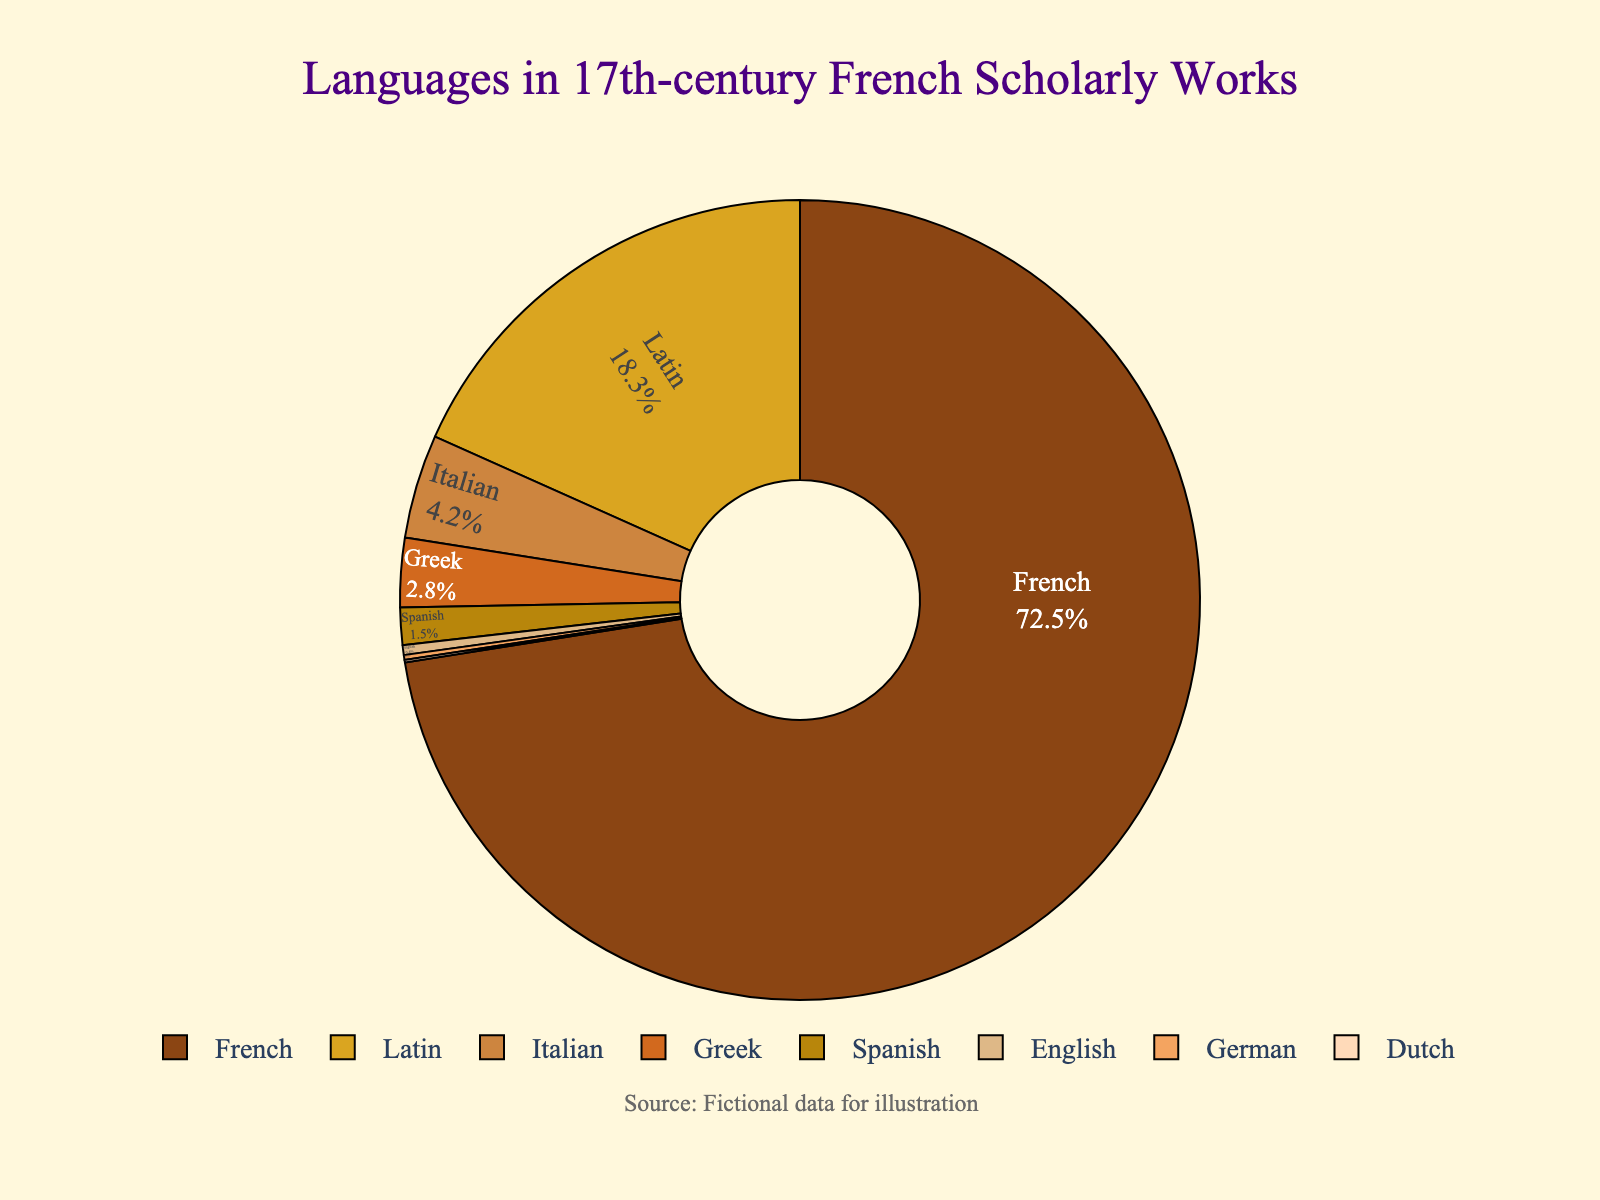Which language is used the most in 17th-century French scholarly works? The pie chart shows that French is the largest segment, indicating it is the most used language in these works.
Answer: French What is the combined percentage of Latin and Greek? By looking at the pie chart, we see Latin has 18.3% and Greek has 2.8%. Adding these together gives 18.3 + 2.8 = 21.1%.
Answer: 21.1% Which languages have a usage percentage higher than 2%? Observing the pie chart, the languages with usage percentages higher than 2% are French (72.5%), Latin (18.3%), Italian (4.2%), and Greek (2.8%).
Answer: French, Latin, Italian, Greek How much more percentage does French have compared to Latin? The pie chart indicates French has 72.5% and Latin has 18.3%. Subtracting the two gives 72.5 - 18.3 = 54.2%.
Answer: 54.2% What is the difference in percentage between Italian and Spanish? The pie chart shows Italian at 4.2% and Spanish at 1.5%. Subtracting these we get 4.2 - 1.5 = 2.7%.
Answer: 2.7% Do Italian and Spanish combined make up more than 5%? Adding the percentages of Italian (4.2%) and Spanish (1.5%) gives 4.2 + 1.5 = 5.7%. This is more than 5%.
Answer: Yes Which language segment is represented with the darkest color? Visually, the darkest segment in the pie chart represents French.
Answer: French Rank the languages from highest to lowest usage. Observing the pie chart, the ranking is: French (72.5%), Latin (18.3%), Italian (4.2%), Greek (2.8%), Spanish (1.5%), English (0.4%), German (0.2%), Dutch (0.1%).
Answer: French, Latin, Italian, Greek, Spanish, English, German, Dutch What is the percentage difference between the least and most used languages? The pie chart indicates French is the most used at 72.5% and Dutch is the least used at 0.1%. Subtracting these gives 72.5 - 0.1 = 72.4%.
Answer: 72.4% 